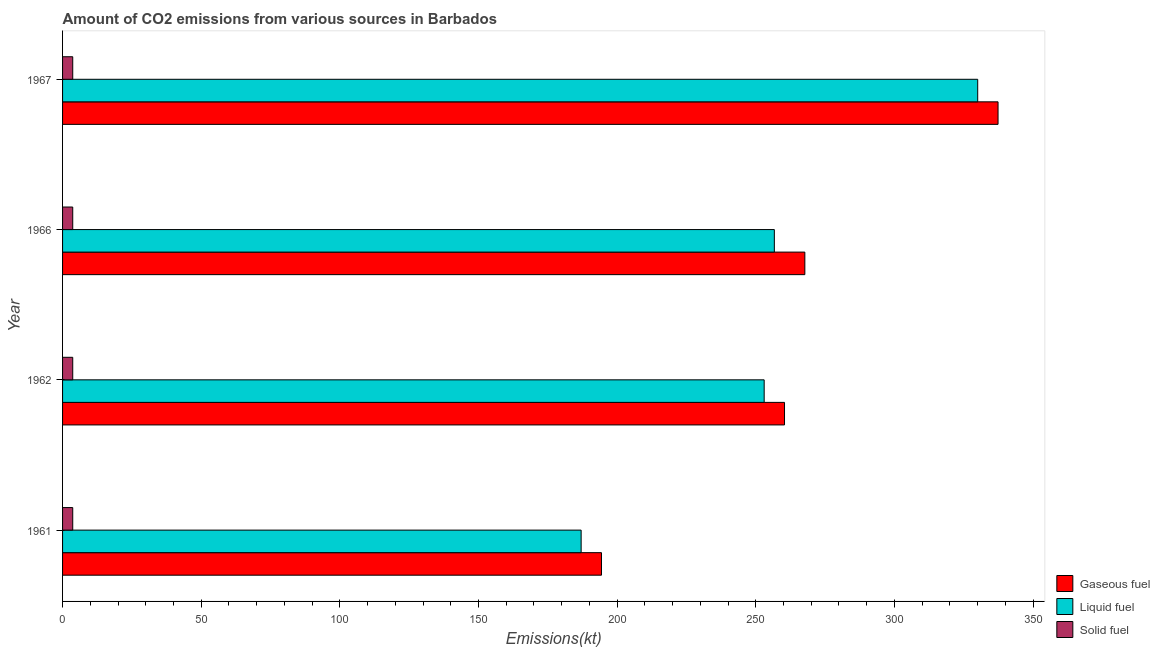How many groups of bars are there?
Your answer should be compact. 4. In how many cases, is the number of bars for a given year not equal to the number of legend labels?
Your response must be concise. 0. What is the amount of co2 emissions from gaseous fuel in 1967?
Your answer should be compact. 337.36. Across all years, what is the maximum amount of co2 emissions from solid fuel?
Offer a very short reply. 3.67. Across all years, what is the minimum amount of co2 emissions from liquid fuel?
Offer a very short reply. 187.02. In which year was the amount of co2 emissions from solid fuel maximum?
Provide a short and direct response. 1961. In which year was the amount of co2 emissions from gaseous fuel minimum?
Your answer should be very brief. 1961. What is the total amount of co2 emissions from gaseous fuel in the graph?
Keep it short and to the point. 1059.76. What is the difference between the amount of co2 emissions from solid fuel in 1966 and that in 1967?
Your answer should be compact. 0. What is the difference between the amount of co2 emissions from solid fuel in 1962 and the amount of co2 emissions from liquid fuel in 1966?
Offer a terse response. -253.02. What is the average amount of co2 emissions from gaseous fuel per year?
Make the answer very short. 264.94. In the year 1962, what is the difference between the amount of co2 emissions from solid fuel and amount of co2 emissions from gaseous fuel?
Your response must be concise. -256.69. In how many years, is the amount of co2 emissions from solid fuel greater than 310 kt?
Offer a terse response. 0. What is the ratio of the amount of co2 emissions from liquid fuel in 1962 to that in 1967?
Your response must be concise. 0.77. What is the difference between the highest and the second highest amount of co2 emissions from gaseous fuel?
Your response must be concise. 69.67. What is the difference between the highest and the lowest amount of co2 emissions from liquid fuel?
Give a very brief answer. 143.01. In how many years, is the amount of co2 emissions from gaseous fuel greater than the average amount of co2 emissions from gaseous fuel taken over all years?
Your response must be concise. 2. What does the 1st bar from the top in 1961 represents?
Ensure brevity in your answer.  Solid fuel. What does the 3rd bar from the bottom in 1966 represents?
Your answer should be very brief. Solid fuel. Is it the case that in every year, the sum of the amount of co2 emissions from gaseous fuel and amount of co2 emissions from liquid fuel is greater than the amount of co2 emissions from solid fuel?
Give a very brief answer. Yes. How many bars are there?
Ensure brevity in your answer.  12. What is the difference between two consecutive major ticks on the X-axis?
Keep it short and to the point. 50. Does the graph contain any zero values?
Offer a terse response. No. How are the legend labels stacked?
Ensure brevity in your answer.  Vertical. What is the title of the graph?
Give a very brief answer. Amount of CO2 emissions from various sources in Barbados. What is the label or title of the X-axis?
Your answer should be very brief. Emissions(kt). What is the label or title of the Y-axis?
Give a very brief answer. Year. What is the Emissions(kt) in Gaseous fuel in 1961?
Provide a succinct answer. 194.35. What is the Emissions(kt) in Liquid fuel in 1961?
Offer a very short reply. 187.02. What is the Emissions(kt) of Solid fuel in 1961?
Provide a succinct answer. 3.67. What is the Emissions(kt) in Gaseous fuel in 1962?
Provide a short and direct response. 260.36. What is the Emissions(kt) in Liquid fuel in 1962?
Your response must be concise. 253.02. What is the Emissions(kt) in Solid fuel in 1962?
Provide a succinct answer. 3.67. What is the Emissions(kt) of Gaseous fuel in 1966?
Ensure brevity in your answer.  267.69. What is the Emissions(kt) in Liquid fuel in 1966?
Your answer should be compact. 256.69. What is the Emissions(kt) of Solid fuel in 1966?
Give a very brief answer. 3.67. What is the Emissions(kt) in Gaseous fuel in 1967?
Ensure brevity in your answer.  337.36. What is the Emissions(kt) of Liquid fuel in 1967?
Your response must be concise. 330.03. What is the Emissions(kt) of Solid fuel in 1967?
Your response must be concise. 3.67. Across all years, what is the maximum Emissions(kt) of Gaseous fuel?
Your answer should be very brief. 337.36. Across all years, what is the maximum Emissions(kt) in Liquid fuel?
Keep it short and to the point. 330.03. Across all years, what is the maximum Emissions(kt) in Solid fuel?
Ensure brevity in your answer.  3.67. Across all years, what is the minimum Emissions(kt) of Gaseous fuel?
Keep it short and to the point. 194.35. Across all years, what is the minimum Emissions(kt) in Liquid fuel?
Keep it short and to the point. 187.02. Across all years, what is the minimum Emissions(kt) in Solid fuel?
Provide a short and direct response. 3.67. What is the total Emissions(kt) of Gaseous fuel in the graph?
Your response must be concise. 1059.76. What is the total Emissions(kt) of Liquid fuel in the graph?
Provide a short and direct response. 1026.76. What is the total Emissions(kt) of Solid fuel in the graph?
Your answer should be compact. 14.67. What is the difference between the Emissions(kt) of Gaseous fuel in 1961 and that in 1962?
Give a very brief answer. -66.01. What is the difference between the Emissions(kt) of Liquid fuel in 1961 and that in 1962?
Your answer should be compact. -66.01. What is the difference between the Emissions(kt) in Gaseous fuel in 1961 and that in 1966?
Ensure brevity in your answer.  -73.34. What is the difference between the Emissions(kt) of Liquid fuel in 1961 and that in 1966?
Ensure brevity in your answer.  -69.67. What is the difference between the Emissions(kt) in Gaseous fuel in 1961 and that in 1967?
Provide a succinct answer. -143.01. What is the difference between the Emissions(kt) of Liquid fuel in 1961 and that in 1967?
Ensure brevity in your answer.  -143.01. What is the difference between the Emissions(kt) in Solid fuel in 1961 and that in 1967?
Your answer should be very brief. 0. What is the difference between the Emissions(kt) of Gaseous fuel in 1962 and that in 1966?
Offer a terse response. -7.33. What is the difference between the Emissions(kt) in Liquid fuel in 1962 and that in 1966?
Give a very brief answer. -3.67. What is the difference between the Emissions(kt) of Solid fuel in 1962 and that in 1966?
Keep it short and to the point. 0. What is the difference between the Emissions(kt) in Gaseous fuel in 1962 and that in 1967?
Offer a terse response. -77.01. What is the difference between the Emissions(kt) of Liquid fuel in 1962 and that in 1967?
Make the answer very short. -77.01. What is the difference between the Emissions(kt) in Gaseous fuel in 1966 and that in 1967?
Give a very brief answer. -69.67. What is the difference between the Emissions(kt) in Liquid fuel in 1966 and that in 1967?
Your response must be concise. -73.34. What is the difference between the Emissions(kt) in Gaseous fuel in 1961 and the Emissions(kt) in Liquid fuel in 1962?
Provide a succinct answer. -58.67. What is the difference between the Emissions(kt) in Gaseous fuel in 1961 and the Emissions(kt) in Solid fuel in 1962?
Offer a very short reply. 190.68. What is the difference between the Emissions(kt) of Liquid fuel in 1961 and the Emissions(kt) of Solid fuel in 1962?
Provide a short and direct response. 183.35. What is the difference between the Emissions(kt) of Gaseous fuel in 1961 and the Emissions(kt) of Liquid fuel in 1966?
Provide a short and direct response. -62.34. What is the difference between the Emissions(kt) in Gaseous fuel in 1961 and the Emissions(kt) in Solid fuel in 1966?
Keep it short and to the point. 190.68. What is the difference between the Emissions(kt) of Liquid fuel in 1961 and the Emissions(kt) of Solid fuel in 1966?
Offer a terse response. 183.35. What is the difference between the Emissions(kt) in Gaseous fuel in 1961 and the Emissions(kt) in Liquid fuel in 1967?
Give a very brief answer. -135.68. What is the difference between the Emissions(kt) in Gaseous fuel in 1961 and the Emissions(kt) in Solid fuel in 1967?
Your response must be concise. 190.68. What is the difference between the Emissions(kt) of Liquid fuel in 1961 and the Emissions(kt) of Solid fuel in 1967?
Give a very brief answer. 183.35. What is the difference between the Emissions(kt) in Gaseous fuel in 1962 and the Emissions(kt) in Liquid fuel in 1966?
Provide a succinct answer. 3.67. What is the difference between the Emissions(kt) of Gaseous fuel in 1962 and the Emissions(kt) of Solid fuel in 1966?
Your answer should be compact. 256.69. What is the difference between the Emissions(kt) in Liquid fuel in 1962 and the Emissions(kt) in Solid fuel in 1966?
Provide a short and direct response. 249.36. What is the difference between the Emissions(kt) in Gaseous fuel in 1962 and the Emissions(kt) in Liquid fuel in 1967?
Make the answer very short. -69.67. What is the difference between the Emissions(kt) in Gaseous fuel in 1962 and the Emissions(kt) in Solid fuel in 1967?
Provide a succinct answer. 256.69. What is the difference between the Emissions(kt) of Liquid fuel in 1962 and the Emissions(kt) of Solid fuel in 1967?
Make the answer very short. 249.36. What is the difference between the Emissions(kt) in Gaseous fuel in 1966 and the Emissions(kt) in Liquid fuel in 1967?
Offer a terse response. -62.34. What is the difference between the Emissions(kt) in Gaseous fuel in 1966 and the Emissions(kt) in Solid fuel in 1967?
Your answer should be very brief. 264.02. What is the difference between the Emissions(kt) in Liquid fuel in 1966 and the Emissions(kt) in Solid fuel in 1967?
Ensure brevity in your answer.  253.02. What is the average Emissions(kt) of Gaseous fuel per year?
Ensure brevity in your answer.  264.94. What is the average Emissions(kt) of Liquid fuel per year?
Make the answer very short. 256.69. What is the average Emissions(kt) of Solid fuel per year?
Make the answer very short. 3.67. In the year 1961, what is the difference between the Emissions(kt) of Gaseous fuel and Emissions(kt) of Liquid fuel?
Your response must be concise. 7.33. In the year 1961, what is the difference between the Emissions(kt) in Gaseous fuel and Emissions(kt) in Solid fuel?
Ensure brevity in your answer.  190.68. In the year 1961, what is the difference between the Emissions(kt) in Liquid fuel and Emissions(kt) in Solid fuel?
Your answer should be very brief. 183.35. In the year 1962, what is the difference between the Emissions(kt) in Gaseous fuel and Emissions(kt) in Liquid fuel?
Ensure brevity in your answer.  7.33. In the year 1962, what is the difference between the Emissions(kt) of Gaseous fuel and Emissions(kt) of Solid fuel?
Your answer should be very brief. 256.69. In the year 1962, what is the difference between the Emissions(kt) of Liquid fuel and Emissions(kt) of Solid fuel?
Provide a succinct answer. 249.36. In the year 1966, what is the difference between the Emissions(kt) of Gaseous fuel and Emissions(kt) of Liquid fuel?
Provide a succinct answer. 11. In the year 1966, what is the difference between the Emissions(kt) in Gaseous fuel and Emissions(kt) in Solid fuel?
Your response must be concise. 264.02. In the year 1966, what is the difference between the Emissions(kt) in Liquid fuel and Emissions(kt) in Solid fuel?
Ensure brevity in your answer.  253.02. In the year 1967, what is the difference between the Emissions(kt) in Gaseous fuel and Emissions(kt) in Liquid fuel?
Keep it short and to the point. 7.33. In the year 1967, what is the difference between the Emissions(kt) of Gaseous fuel and Emissions(kt) of Solid fuel?
Your answer should be compact. 333.7. In the year 1967, what is the difference between the Emissions(kt) in Liquid fuel and Emissions(kt) in Solid fuel?
Make the answer very short. 326.36. What is the ratio of the Emissions(kt) of Gaseous fuel in 1961 to that in 1962?
Your response must be concise. 0.75. What is the ratio of the Emissions(kt) in Liquid fuel in 1961 to that in 1962?
Make the answer very short. 0.74. What is the ratio of the Emissions(kt) in Gaseous fuel in 1961 to that in 1966?
Ensure brevity in your answer.  0.73. What is the ratio of the Emissions(kt) of Liquid fuel in 1961 to that in 1966?
Make the answer very short. 0.73. What is the ratio of the Emissions(kt) in Gaseous fuel in 1961 to that in 1967?
Make the answer very short. 0.58. What is the ratio of the Emissions(kt) of Liquid fuel in 1961 to that in 1967?
Give a very brief answer. 0.57. What is the ratio of the Emissions(kt) of Gaseous fuel in 1962 to that in 1966?
Your answer should be compact. 0.97. What is the ratio of the Emissions(kt) of Liquid fuel in 1962 to that in 1966?
Provide a short and direct response. 0.99. What is the ratio of the Emissions(kt) in Solid fuel in 1962 to that in 1966?
Your response must be concise. 1. What is the ratio of the Emissions(kt) of Gaseous fuel in 1962 to that in 1967?
Your response must be concise. 0.77. What is the ratio of the Emissions(kt) of Liquid fuel in 1962 to that in 1967?
Give a very brief answer. 0.77. What is the ratio of the Emissions(kt) of Gaseous fuel in 1966 to that in 1967?
Your answer should be very brief. 0.79. What is the ratio of the Emissions(kt) in Liquid fuel in 1966 to that in 1967?
Ensure brevity in your answer.  0.78. What is the difference between the highest and the second highest Emissions(kt) in Gaseous fuel?
Give a very brief answer. 69.67. What is the difference between the highest and the second highest Emissions(kt) in Liquid fuel?
Provide a succinct answer. 73.34. What is the difference between the highest and the lowest Emissions(kt) in Gaseous fuel?
Your response must be concise. 143.01. What is the difference between the highest and the lowest Emissions(kt) in Liquid fuel?
Your answer should be very brief. 143.01. What is the difference between the highest and the lowest Emissions(kt) of Solid fuel?
Offer a terse response. 0. 